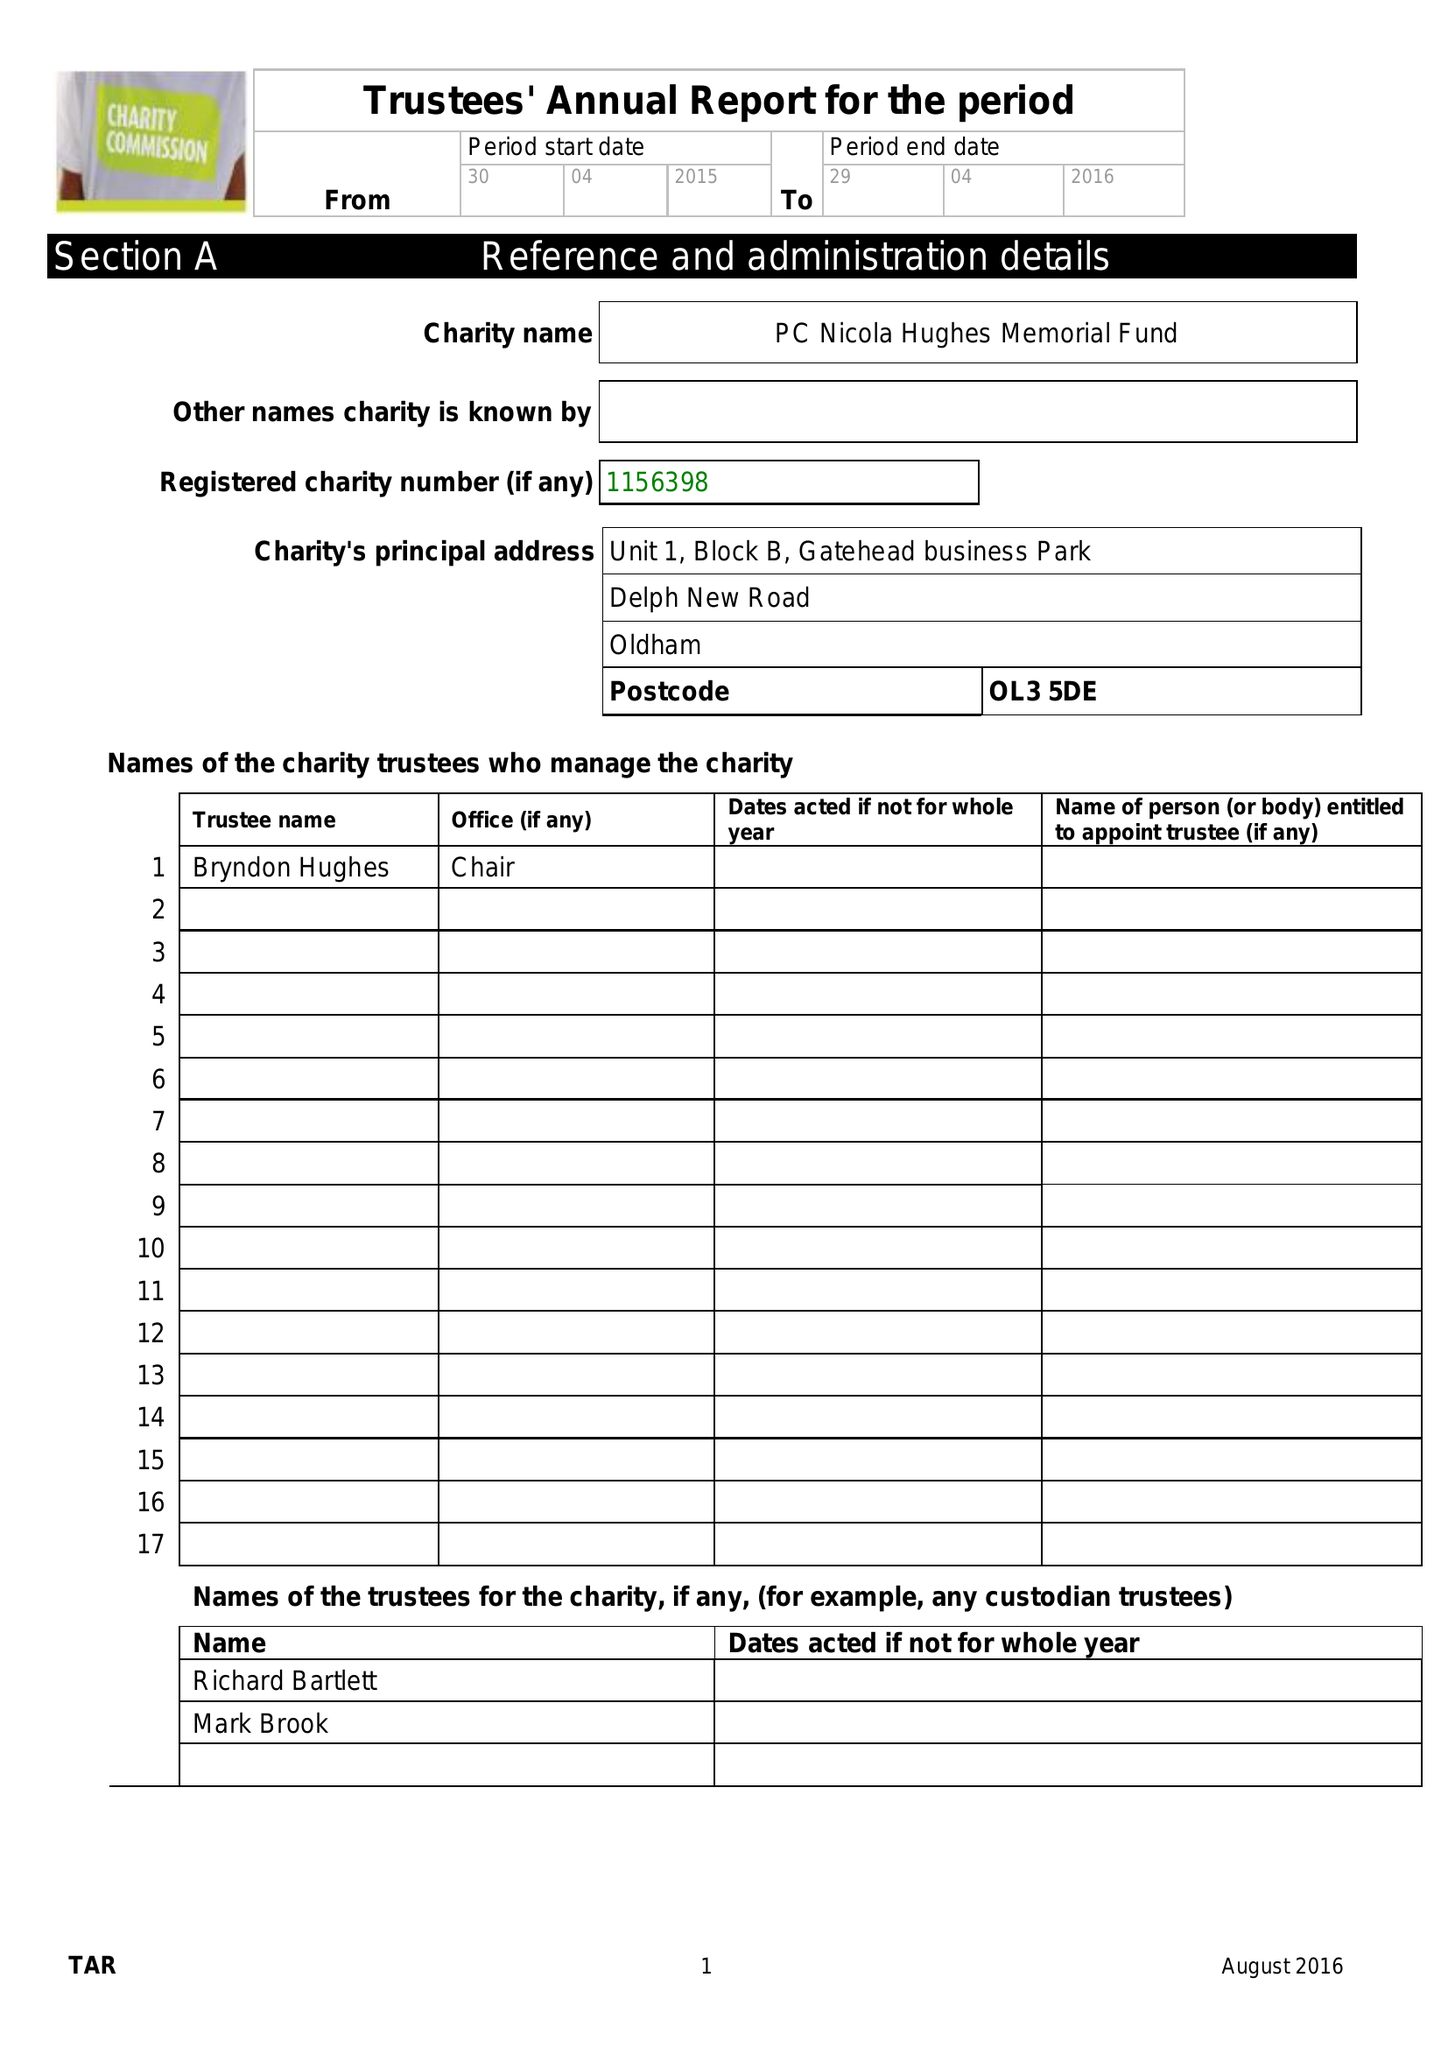What is the value for the address__postcode?
Answer the question using a single word or phrase. OL3 5DE 